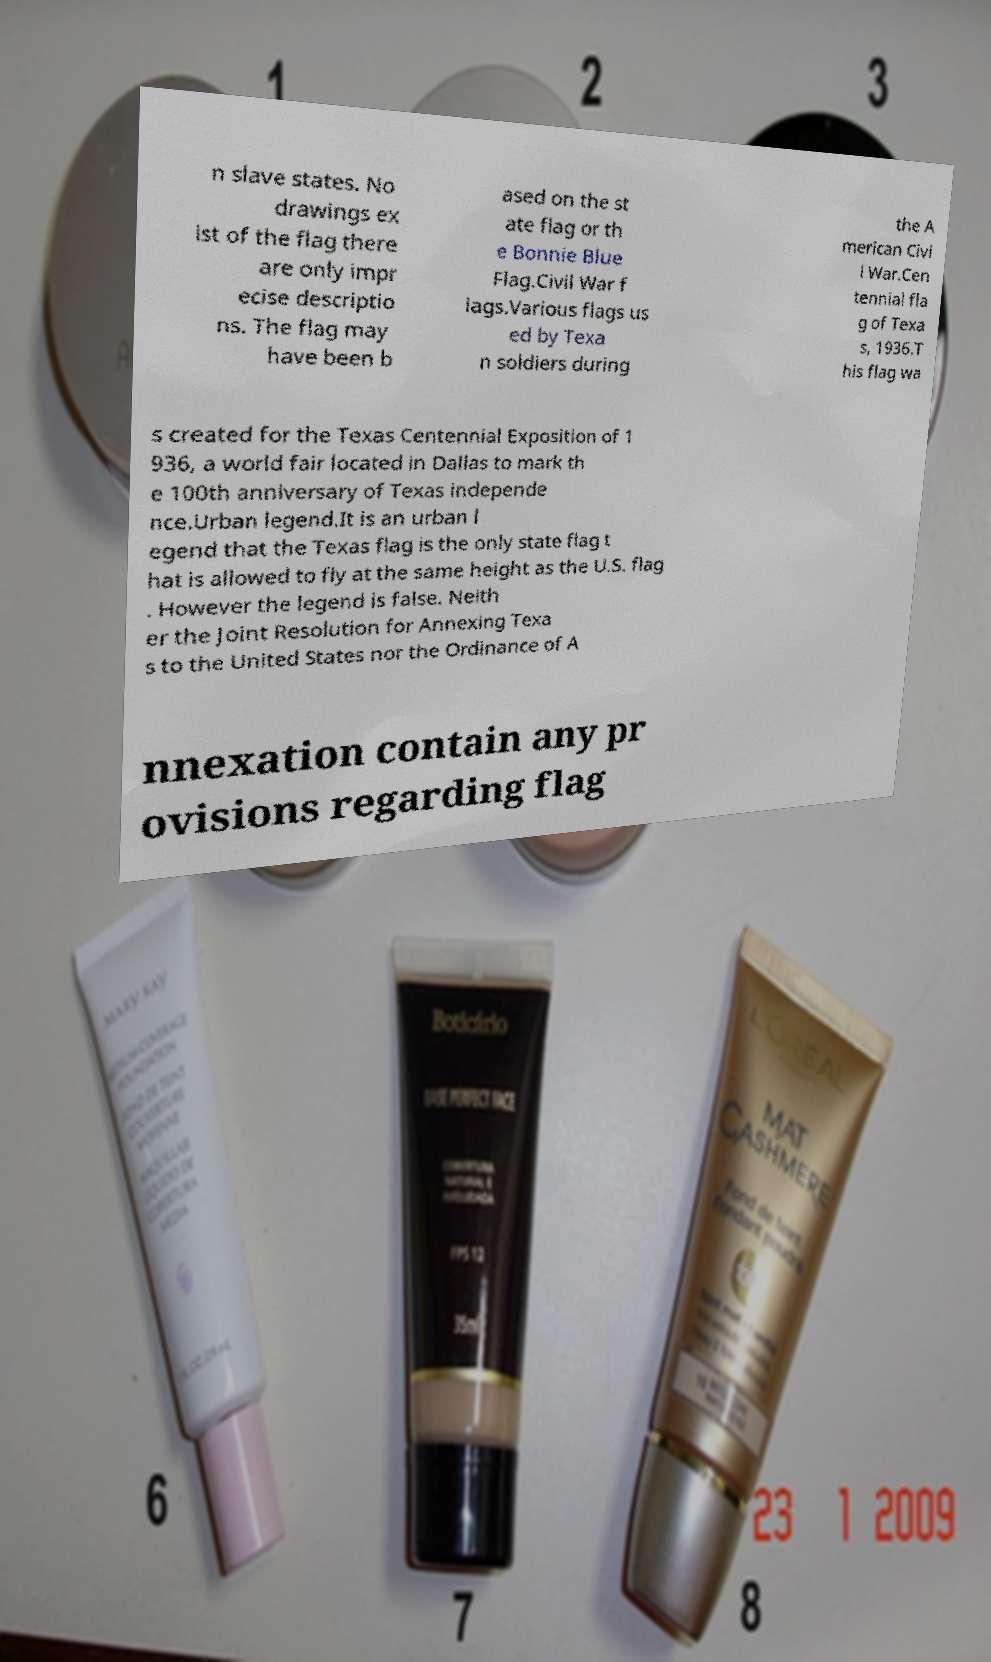Could you extract and type out the text from this image? n slave states. No drawings ex ist of the flag there are only impr ecise descriptio ns. The flag may have been b ased on the st ate flag or th e Bonnie Blue Flag.Civil War f lags.Various flags us ed by Texa n soldiers during the A merican Civi l War.Cen tennial fla g of Texa s, 1936.T his flag wa s created for the Texas Centennial Exposition of 1 936, a world fair located in Dallas to mark th e 100th anniversary of Texas independe nce.Urban legend.It is an urban l egend that the Texas flag is the only state flag t hat is allowed to fly at the same height as the U.S. flag . However the legend is false. Neith er the Joint Resolution for Annexing Texa s to the United States nor the Ordinance of A nnexation contain any pr ovisions regarding flag 